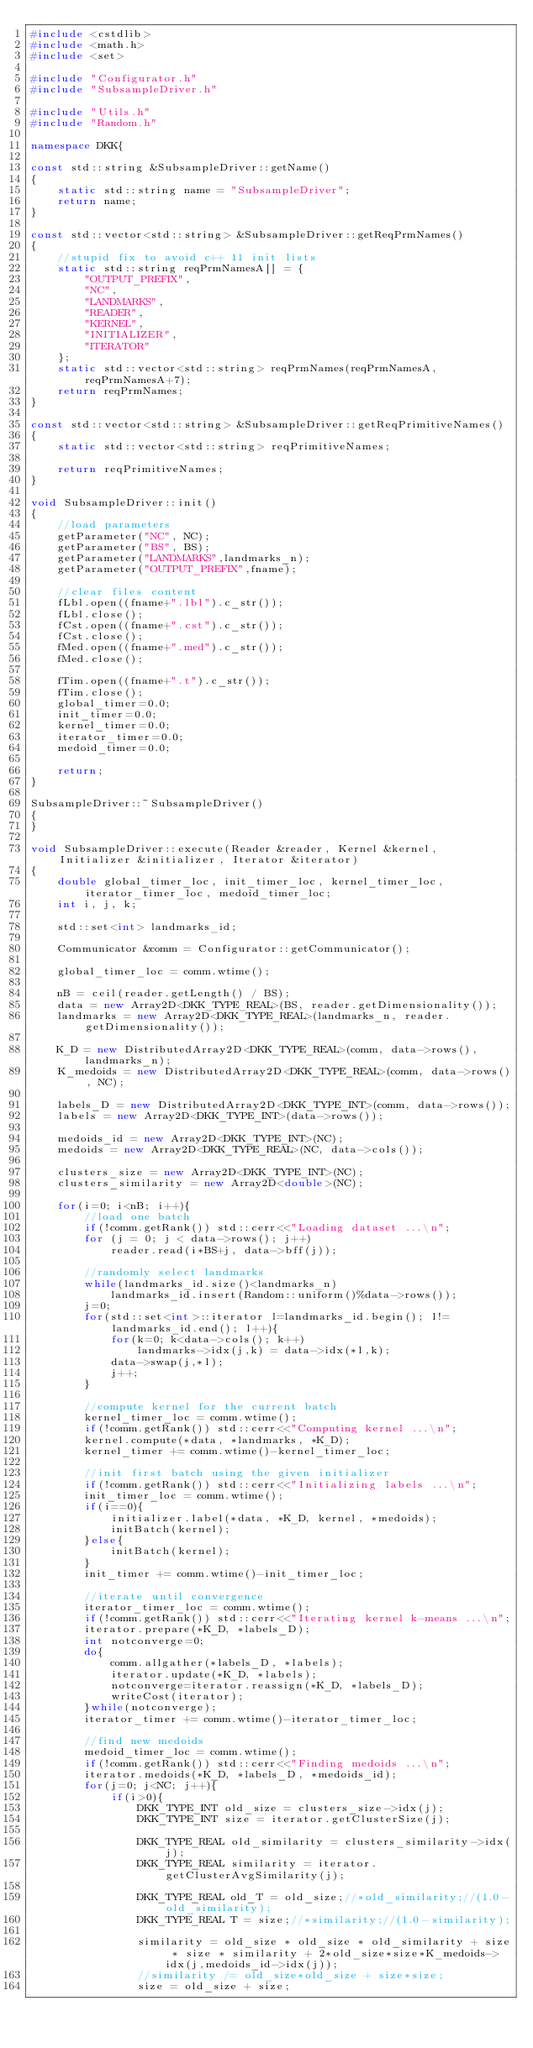Convert code to text. <code><loc_0><loc_0><loc_500><loc_500><_C++_>#include <cstdlib>
#include <math.h>
#include <set>

#include "Configurator.h"
#include "SubsampleDriver.h"

#include "Utils.h"
#include "Random.h"

namespace DKK{

const std::string &SubsampleDriver::getName()
{
	static std::string name = "SubsampleDriver";
	return name;
}

const std::vector<std::string> &SubsampleDriver::getReqPrmNames()
{
	//stupid fix to avoid c++ 11 init lists
	static std::string reqPrmNamesA[] = {
		"OUTPUT_PREFIX",
		"NC",
		"LANDMARKS",
		"READER",
		"KERNEL",
		"INITIALIZER",
		"ITERATOR"
	};
	static std::vector<std::string> reqPrmNames(reqPrmNamesA, reqPrmNamesA+7);
	return reqPrmNames;
}

const std::vector<std::string> &SubsampleDriver::getReqPrimitiveNames()
{
	static std::vector<std::string> reqPrimitiveNames;

	return reqPrimitiveNames;
}

void SubsampleDriver::init()
{
	//load parameters
	getParameter("NC", NC);
	getParameter("BS", BS);
	getParameter("LANDMARKS",landmarks_n);
	getParameter("OUTPUT_PREFIX",fname);

	//clear files content
	fLbl.open((fname+".lbl").c_str());
	fLbl.close();
	fCst.open((fname+".cst").c_str());
	fCst.close();
	fMed.open((fname+".med").c_str());
	fMed.close();

	fTim.open((fname+".t").c_str());
	fTim.close();
	global_timer=0.0;
	init_timer=0.0;
	kernel_timer=0.0;
	iterator_timer=0.0;
	medoid_timer=0.0;

	return;
}

SubsampleDriver::~SubsampleDriver()
{
}

void SubsampleDriver::execute(Reader &reader, Kernel &kernel, Initializer &initializer, Iterator &iterator)
{
	double global_timer_loc, init_timer_loc, kernel_timer_loc, iterator_timer_loc, medoid_timer_loc;
	int i, j, k;

	std::set<int> landmarks_id;

	Communicator &comm = Configurator::getCommunicator();

	global_timer_loc = comm.wtime();

	nB = ceil(reader.getLength() / BS);
	data = new Array2D<DKK_TYPE_REAL>(BS, reader.getDimensionality());
	landmarks = new Array2D<DKK_TYPE_REAL>(landmarks_n, reader.getDimensionality());

	K_D = new DistributedArray2D<DKK_TYPE_REAL>(comm, data->rows(), landmarks_n);
	K_medoids = new DistributedArray2D<DKK_TYPE_REAL>(comm, data->rows(), NC);

	labels_D = new DistributedArray2D<DKK_TYPE_INT>(comm, data->rows());
	labels = new Array2D<DKK_TYPE_INT>(data->rows());

	medoids_id = new Array2D<DKK_TYPE_INT>(NC);
	medoids = new Array2D<DKK_TYPE_REAL>(NC, data->cols());

	clusters_size = new Array2D<DKK_TYPE_INT>(NC);
	clusters_similarity = new Array2D<double>(NC);

	for(i=0; i<nB; i++){
		//load one batch
		if(!comm.getRank()) std::cerr<<"Loading dataset ...\n";
		for (j = 0; j < data->rows(); j++)
			reader.read(i*BS+j, data->bff(j));

		//randomly select landmarks	
		while(landmarks_id.size()<landmarks_n)
			landmarks_id.insert(Random::uniform()%data->rows());
		j=0;
		for(std::set<int>::iterator l=landmarks_id.begin(); l!=landmarks_id.end(); l++){
			for(k=0; k<data->cols(); k++)
				landmarks->idx(j,k) = data->idx(*l,k);
			data->swap(j,*l);
			j++;
		}

		//compute kernel for the current batch
		kernel_timer_loc = comm.wtime();
		if(!comm.getRank()) std::cerr<<"Computing kernel ...\n";
		kernel.compute(*data, *landmarks, *K_D);
		kernel_timer += comm.wtime()-kernel_timer_loc;

		//init first batch using the given initializer
		if(!comm.getRank()) std::cerr<<"Initializing labels ...\n";
		init_timer_loc = comm.wtime();
		if(i==0){
			initializer.label(*data, *K_D, kernel, *medoids);
			initBatch(kernel);
		}else{
			initBatch(kernel);
		}
		init_timer += comm.wtime()-init_timer_loc;
		
		//iterate until convergence
		iterator_timer_loc = comm.wtime();
		if(!comm.getRank()) std::cerr<<"Iterating kernel k-means ...\n";
		iterator.prepare(*K_D, *labels_D);
		int notconverge=0;
		do{
			comm.allgather(*labels_D, *labels);
			iterator.update(*K_D, *labels);
			notconverge=iterator.reassign(*K_D, *labels_D);
			writeCost(iterator);
		}while(notconverge);
		iterator_timer += comm.wtime()-iterator_timer_loc;

		//find new medoids
		medoid_timer_loc = comm.wtime();
		if(!comm.getRank()) std::cerr<<"Finding medoids ...\n";
		iterator.medoids(*K_D, *labels_D, *medoids_id);
		for(j=0; j<NC; j++){
			if(i>0){
				DKK_TYPE_INT old_size = clusters_size->idx(j);
				DKK_TYPE_INT size = iterator.getClusterSize(j);

				DKK_TYPE_REAL old_similarity = clusters_similarity->idx(j);
				DKK_TYPE_REAL similarity = iterator.getClusterAvgSimilarity(j);

				DKK_TYPE_REAL old_T = old_size;//*old_similarity;//(1.0-old_similarity);
				DKK_TYPE_REAL T = size;//*similarity;//(1.0-similarity);

				similarity = old_size * old_size * old_similarity + size * size * similarity + 2*old_size*size*K_medoids->idx(j,medoids_id->idx(j));
				//similarity /= old_size*old_size + size*size;
				size = old_size + size;</code> 